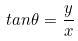<formula> <loc_0><loc_0><loc_500><loc_500>t a n \theta = \frac { y } { x }</formula> 